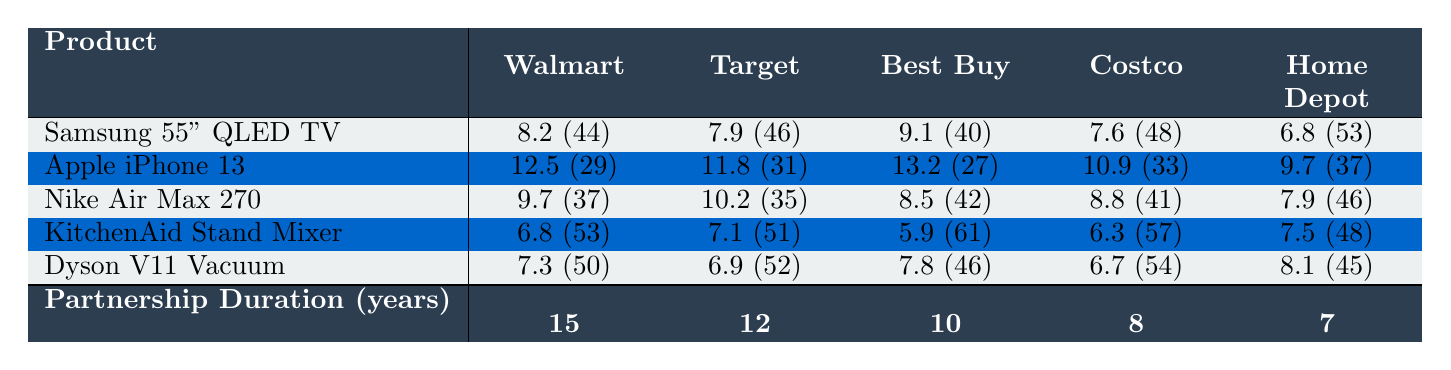What is the inventory turnover rate for the Apple iPhone 13 at Best Buy? The table shows that the inventory turnover rate for the Apple iPhone 13 at Best Buy is 13.2.
Answer: 13.2 Which retail partner has the highest inventory turnover rate for the Dyson V11 Vacuum? According to the table, Best Buy has the highest inventory turnover rate for the Dyson V11 Vacuum at 7.8.
Answer: Best Buy What is the average inventory turnover rate for the Samsung 55" QLED TV across all retail partners? To calculate the average, sum the inventory turnover rates: (8.2 + 7.9 + 9.1 + 7.6 + 6.8) = 39.6. Dividing by 5 gives an average of 39.6 / 5 = 7.92.
Answer: 7.92 Which product has the longest average days on shelf at Walmart? The table lists the average days on shelf for products at Walmart, and the KitchenAid Stand Mixer has the longest at 53 days.
Answer: KitchenAid Stand Mixer Does Target have a higher inventory turnover rate for the Nike Air Max 270 than Costco? The table shows Target has an inventory turnover rate of 10.2 for the Nike Air Max 270 while Costco has 8.8; thus, Target does have a higher rate.
Answer: Yes What is the difference in inventory turnover rates for the Samsung 55" QLED TV between Walmart and Home Depot? Walmart's inventory turnover rate for the Samsung 55" QLED TV is 8.2 while Home Depot's is 6.8. The difference is 8.2 - 6.8 = 1.4.
Answer: 1.4 For which product does Costco have the lowest inventory turnover rate? By examining the table, the product with the lowest inventory turnover at Costco is the KitchenAid Stand Mixer, which has a rate of 6.3.
Answer: KitchenAid Stand Mixer What is the median inventory turnover rate for the Apple iPhone 13 across all retail partners? Listing the turnover rates: 9.7 (Home Depot), 10.9 (Costco), 11.8 (Target), 12.5 (Walmart), and 13.2 (Best Buy). In order: 9.7, 10.9, 11.8, 12.5, 13.2. The median (middle value) is 11.8.
Answer: 11.8 How do the inventory turnover rates for Dyson V11 Vacuum compare between Walmart and Target? At Walmart, the rate is 7.3, while at Target it is 6.9. Walmart's rate is higher by 7.3 - 6.9 = 0.4.
Answer: Walmart's is higher by 0.4 Which retail partner has the longest partnership duration? The table indicates Walmart has the longest partnership duration at 15 years.
Answer: Walmart 